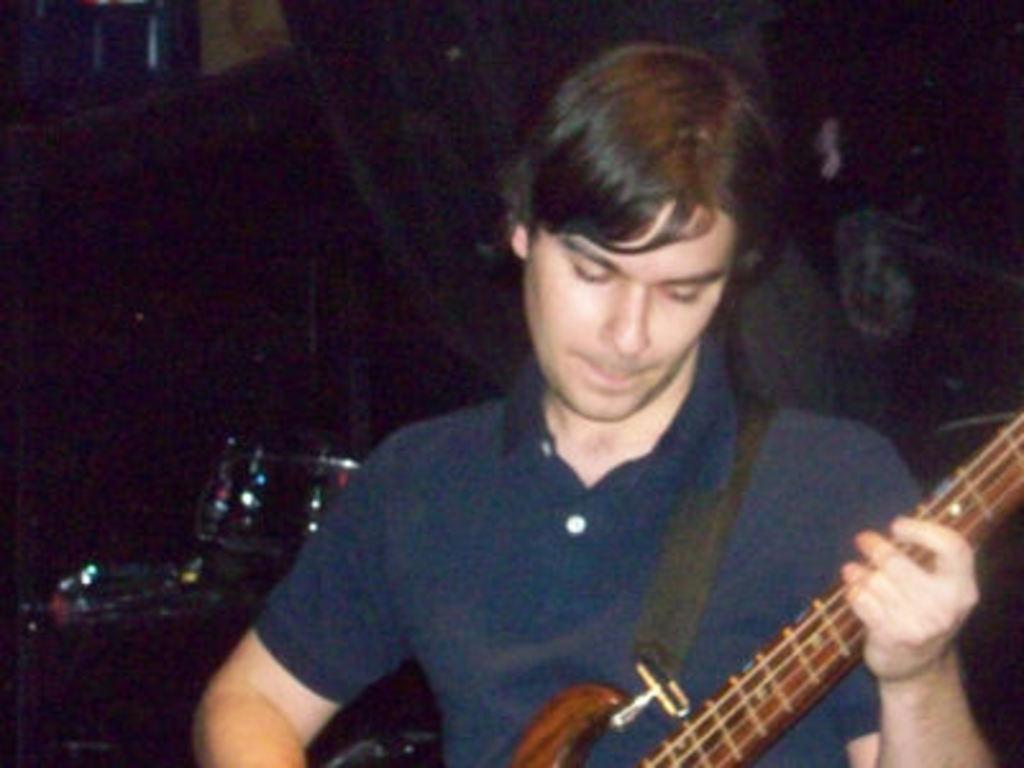What is the man in the image doing? The man is holding a guitar in the image. What might the man be focused on or looking at? The man is looking at something in the image. What type of line is the man drawing on the ground with his shoe in the image? There is no line or shoe drawing activity present in the image. 